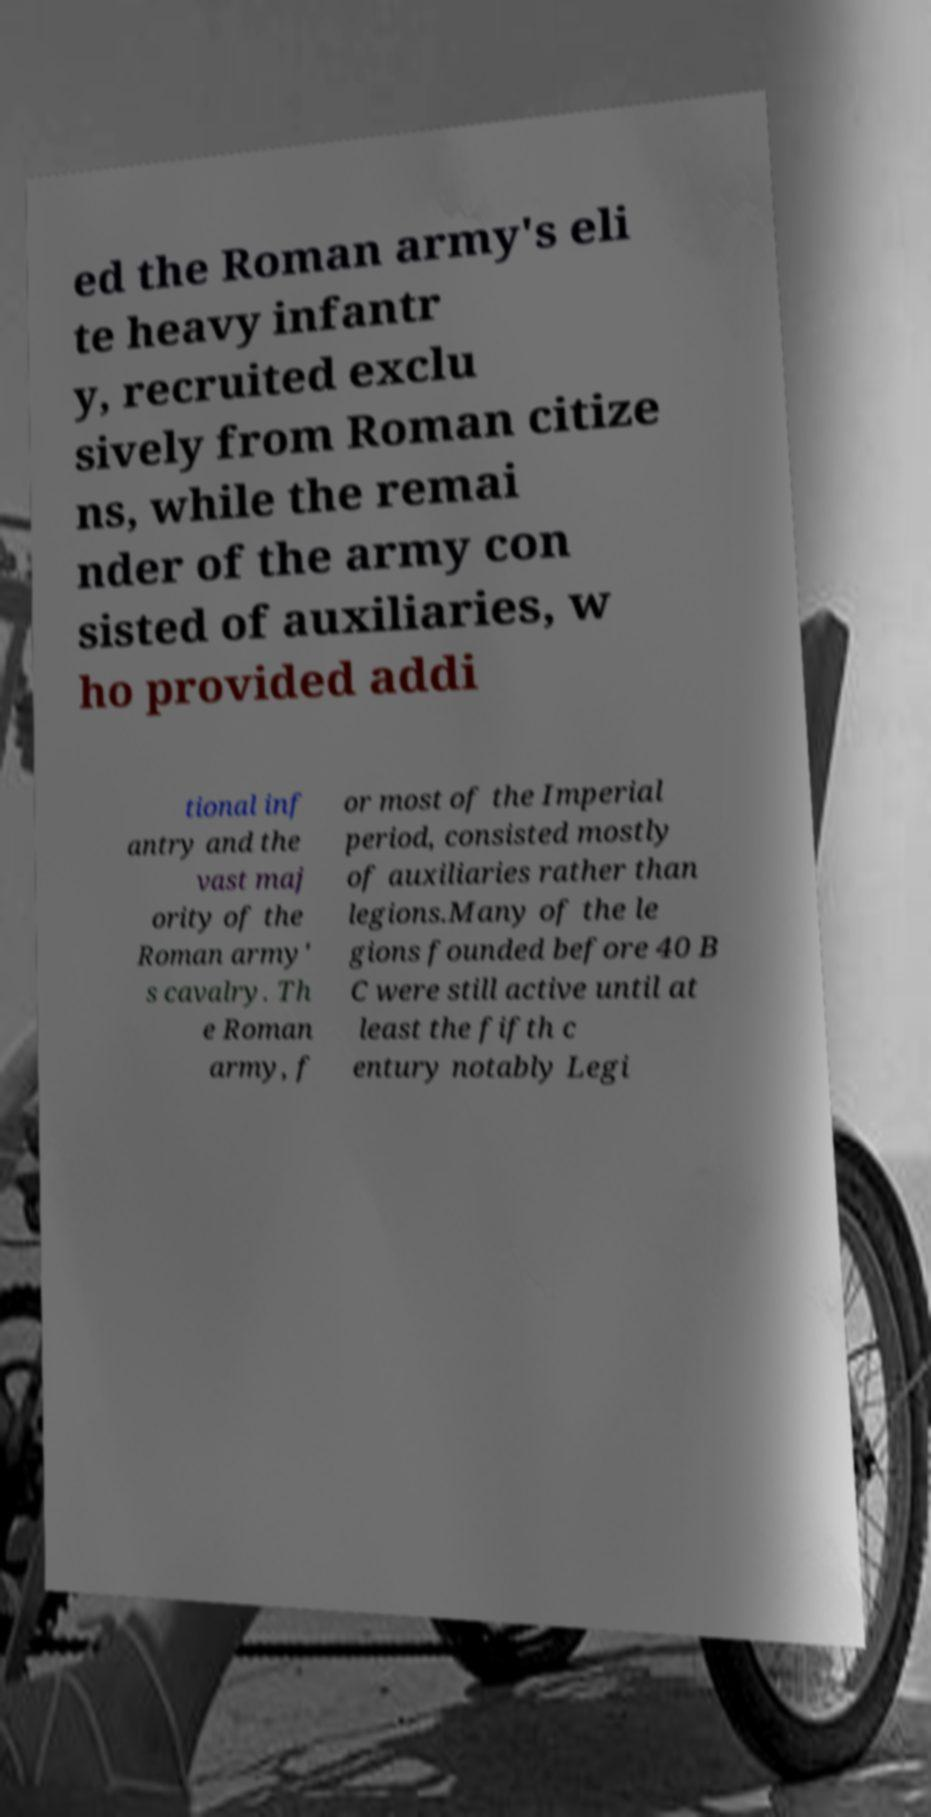Could you assist in decoding the text presented in this image and type it out clearly? ed the Roman army's eli te heavy infantr y, recruited exclu sively from Roman citize ns, while the remai nder of the army con sisted of auxiliaries, w ho provided addi tional inf antry and the vast maj ority of the Roman army' s cavalry. Th e Roman army, f or most of the Imperial period, consisted mostly of auxiliaries rather than legions.Many of the le gions founded before 40 B C were still active until at least the fifth c entury notably Legi 